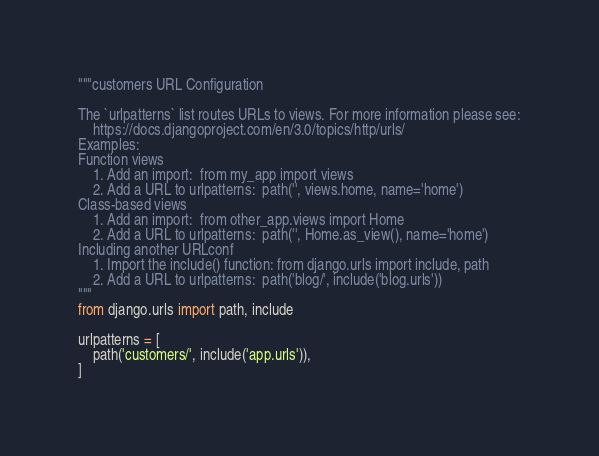<code> <loc_0><loc_0><loc_500><loc_500><_Python_>"""customers URL Configuration

The `urlpatterns` list routes URLs to views. For more information please see:
    https://docs.djangoproject.com/en/3.0/topics/http/urls/
Examples:
Function views
    1. Add an import:  from my_app import views
    2. Add a URL to urlpatterns:  path('', views.home, name='home')
Class-based views
    1. Add an import:  from other_app.views import Home
    2. Add a URL to urlpatterns:  path('', Home.as_view(), name='home')
Including another URLconf
    1. Import the include() function: from django.urls import include, path
    2. Add a URL to urlpatterns:  path('blog/', include('blog.urls'))
"""
from django.urls import path, include

urlpatterns = [
    path('customers/', include('app.urls')),
]
</code> 